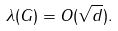<formula> <loc_0><loc_0><loc_500><loc_500>\lambda ( G ) = O ( \sqrt { d } ) .</formula> 